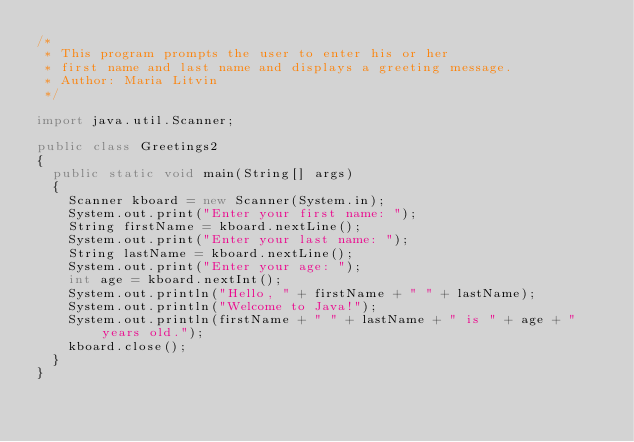Convert code to text. <code><loc_0><loc_0><loc_500><loc_500><_Java_>/*
 * This program prompts the user to enter his or her
 * first name and last name and displays a greeting message.
 * Author: Maria Litvin
 */

import java.util.Scanner;

public class Greetings2
{
  public static void main(String[] args)
  {
    Scanner kboard = new Scanner(System.in);
    System.out.print("Enter your first name: ");
    String firstName = kboard.nextLine();
    System.out.print("Enter your last name: ");
    String lastName = kboard.nextLine();
    System.out.print("Enter your age: ");
    int age = kboard.nextInt();
    System.out.println("Hello, " + firstName + " " + lastName);
    System.out.println("Welcome to Java!");
    System.out.println(firstName + " " + lastName + " is " + age + " years old.");
    kboard.close();
  }
}
</code> 